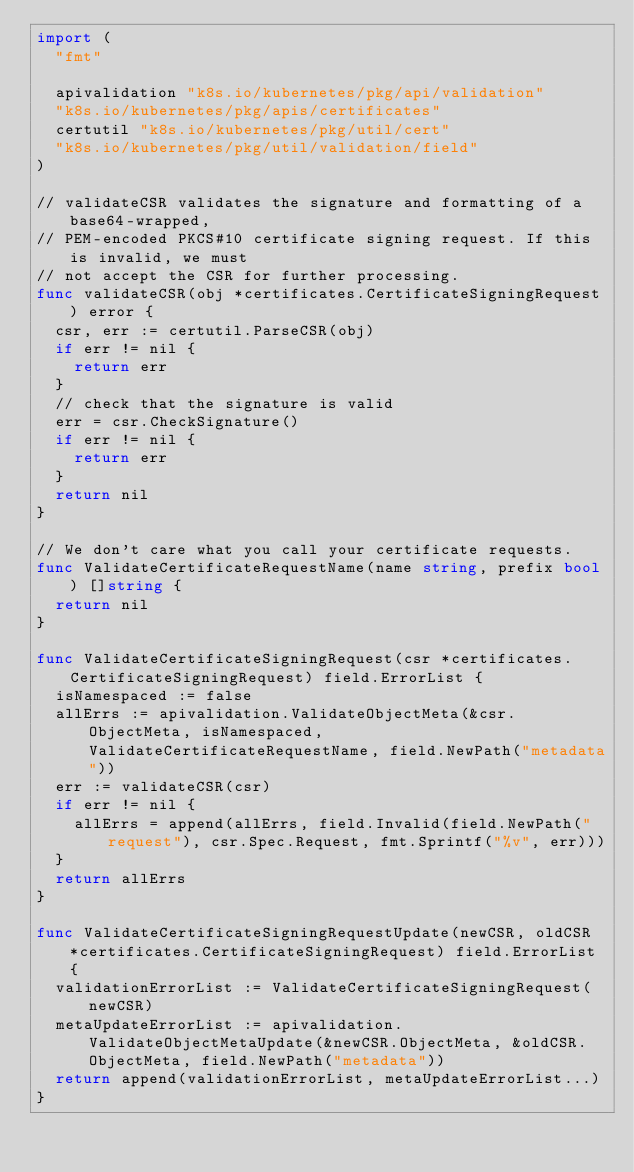Convert code to text. <code><loc_0><loc_0><loc_500><loc_500><_Go_>import (
	"fmt"

	apivalidation "k8s.io/kubernetes/pkg/api/validation"
	"k8s.io/kubernetes/pkg/apis/certificates"
	certutil "k8s.io/kubernetes/pkg/util/cert"
	"k8s.io/kubernetes/pkg/util/validation/field"
)

// validateCSR validates the signature and formatting of a base64-wrapped,
// PEM-encoded PKCS#10 certificate signing request. If this is invalid, we must
// not accept the CSR for further processing.
func validateCSR(obj *certificates.CertificateSigningRequest) error {
	csr, err := certutil.ParseCSR(obj)
	if err != nil {
		return err
	}
	// check that the signature is valid
	err = csr.CheckSignature()
	if err != nil {
		return err
	}
	return nil
}

// We don't care what you call your certificate requests.
func ValidateCertificateRequestName(name string, prefix bool) []string {
	return nil
}

func ValidateCertificateSigningRequest(csr *certificates.CertificateSigningRequest) field.ErrorList {
	isNamespaced := false
	allErrs := apivalidation.ValidateObjectMeta(&csr.ObjectMeta, isNamespaced, ValidateCertificateRequestName, field.NewPath("metadata"))
	err := validateCSR(csr)
	if err != nil {
		allErrs = append(allErrs, field.Invalid(field.NewPath("request"), csr.Spec.Request, fmt.Sprintf("%v", err)))
	}
	return allErrs
}

func ValidateCertificateSigningRequestUpdate(newCSR, oldCSR *certificates.CertificateSigningRequest) field.ErrorList {
	validationErrorList := ValidateCertificateSigningRequest(newCSR)
	metaUpdateErrorList := apivalidation.ValidateObjectMetaUpdate(&newCSR.ObjectMeta, &oldCSR.ObjectMeta, field.NewPath("metadata"))
	return append(validationErrorList, metaUpdateErrorList...)
}
</code> 